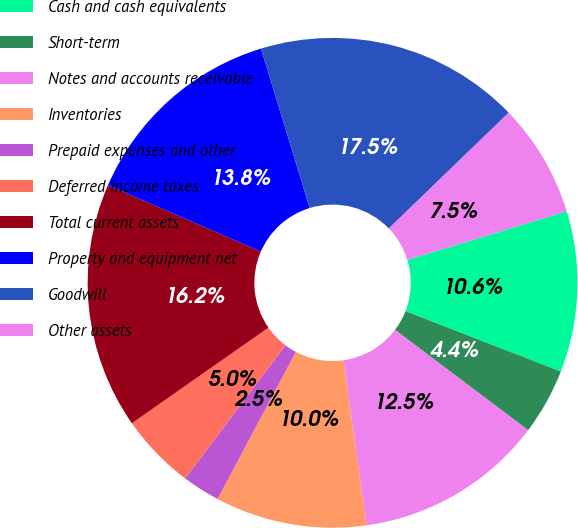<chart> <loc_0><loc_0><loc_500><loc_500><pie_chart><fcel>Cash and cash equivalents<fcel>Short-term<fcel>Notes and accounts receivable<fcel>Inventories<fcel>Prepaid expenses and other<fcel>Deferred income taxes<fcel>Total current assets<fcel>Property and equipment net<fcel>Goodwill<fcel>Other assets<nl><fcel>10.62%<fcel>4.38%<fcel>12.5%<fcel>10.0%<fcel>2.5%<fcel>5.0%<fcel>16.25%<fcel>13.75%<fcel>17.5%<fcel>7.5%<nl></chart> 